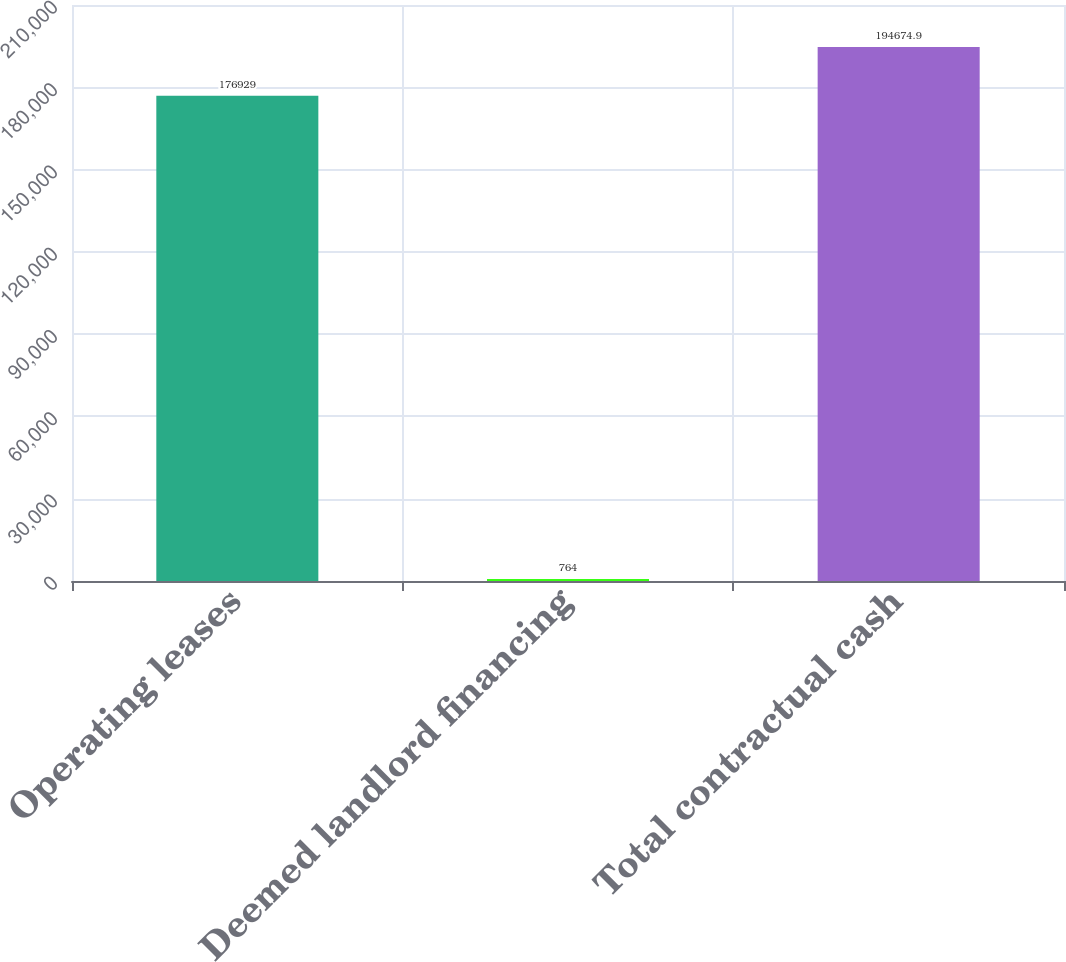<chart> <loc_0><loc_0><loc_500><loc_500><bar_chart><fcel>Operating leases<fcel>Deemed landlord financing<fcel>Total contractual cash<nl><fcel>176929<fcel>764<fcel>194675<nl></chart> 